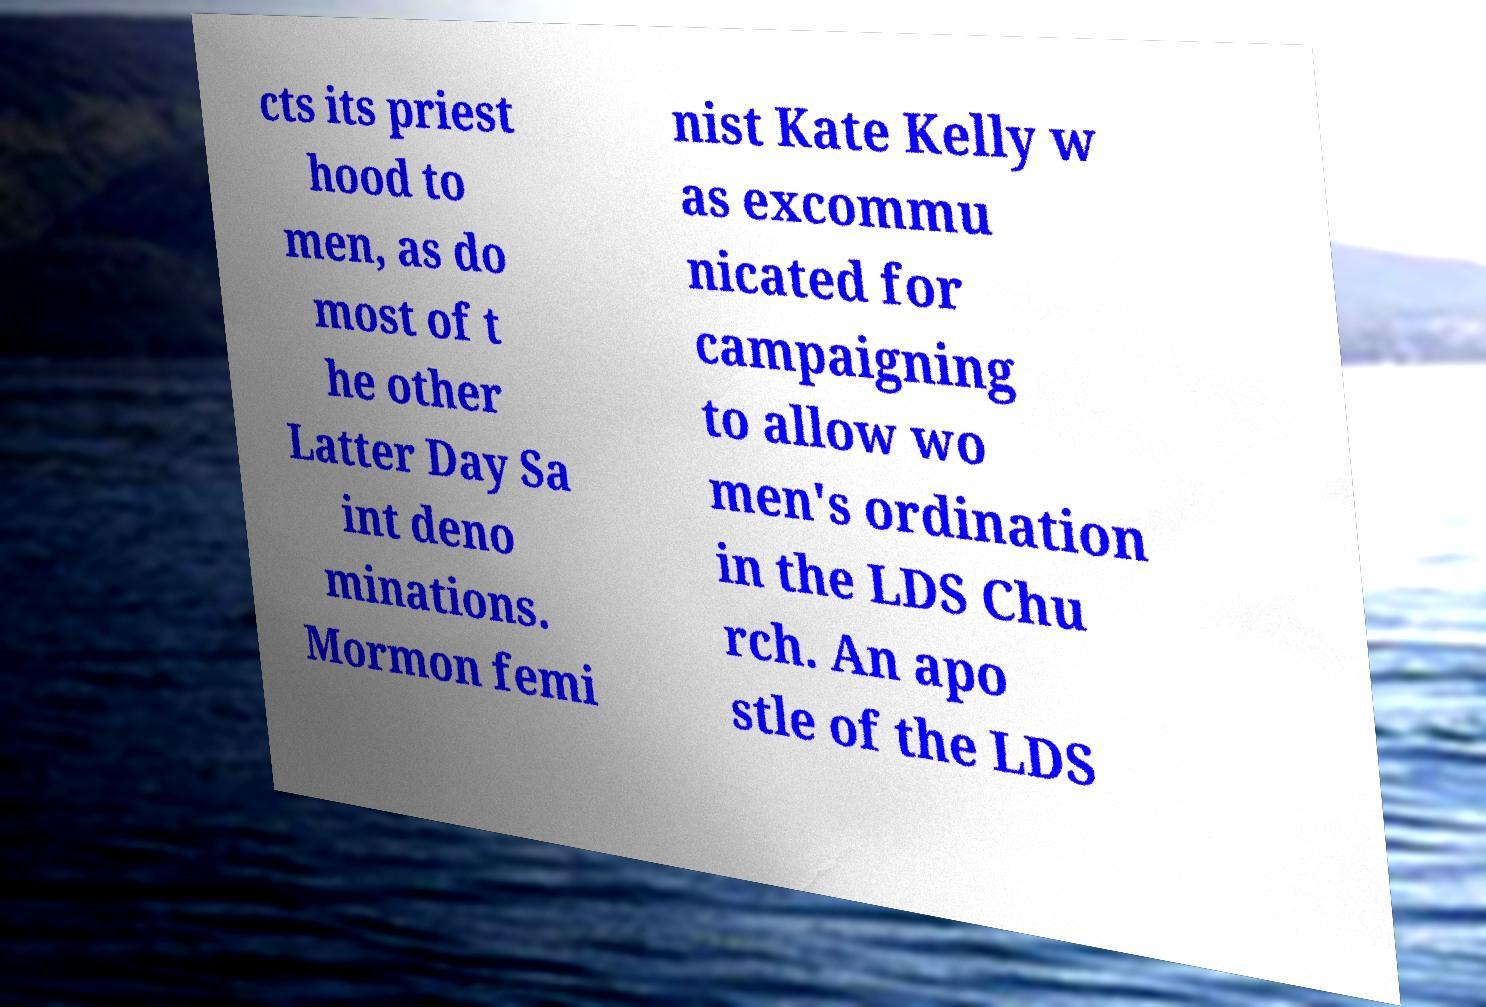For documentation purposes, I need the text within this image transcribed. Could you provide that? cts its priest hood to men, as do most of t he other Latter Day Sa int deno minations. Mormon femi nist Kate Kelly w as excommu nicated for campaigning to allow wo men's ordination in the LDS Chu rch. An apo stle of the LDS 